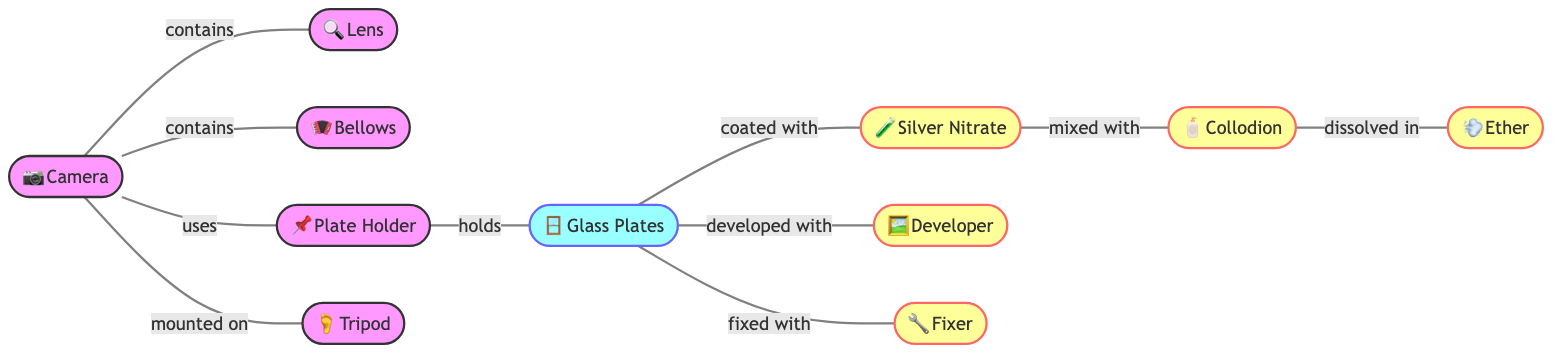What nodes are part of the diagram? The diagram contains nodes representing various components of 19th-century photography equipment: Camera, Lens, Bellows, Plate Holder, Tripod, Silver Nitrate, Collodion, Ether, Developer, Fixer, and Glass Plates. Each of these nodes is directly linked to show relationships in the photography process.
Answer: Camera, Lens, Bellows, Plate Holder, Tripod, Silver Nitrate, Collodion, Ether, Developer, Fixer, Glass Plates How many edges are in the diagram? The diagram has 10 edges, which connect the various nodes and describe the relationships between the components. Each edge represents a specific interaction or connection, such as 'contains' or 'mixed with.'
Answer: 10 What component is mounted on the Tripod? The diagram shows that the Camera is the component that is mounted on the Tripod, indicating its reliance on the Tripod for stability during photography.
Answer: Camera Which chemical is mixed with Silver Nitrate? According to the diagram, Collodion is mixed with Silver Nitrate. This relationship indicates that these two chemicals are combined to prepare for the photographic process.
Answer: Collodion What do Glass Plates develop with? The relationship shown in the diagram indicates that Glass Plates are developed with Developer. This component is crucial for processing the image captured on the plates.
Answer: Developer What does the Plate Holder hold? The diagram states that the Plate Holder holds Glass Plates, which are essential for capturing photographs. This hierarchical relationship signifies the function of the Plate Holder.
Answer: Glass Plates Which component is dissolved in Ether? As per the diagram, Collodion is the component that is dissolved in Ether, highlighting the preparation process of Collodion for use with Glass Plates.
Answer: Collodion How many components does the Camera contain? The diagram illustrates that the Camera contains three components: Lens, Bellows, and it uses a Plate Holder. Therefore, it directly incorporates these three parts in its structure.
Answer: 3 What materials do Glass Plates get fixed with? From the diagram, Glass Plates get fixed with Fixer. This indicates the chemical process that ensures image permanence after development.
Answer: Fixer What is coated on Glass Plates? The diagram specifies that Glass Plates are coated with Silver Nitrate, which is a critical step in preparing the plates for photography.
Answer: Silver Nitrate 